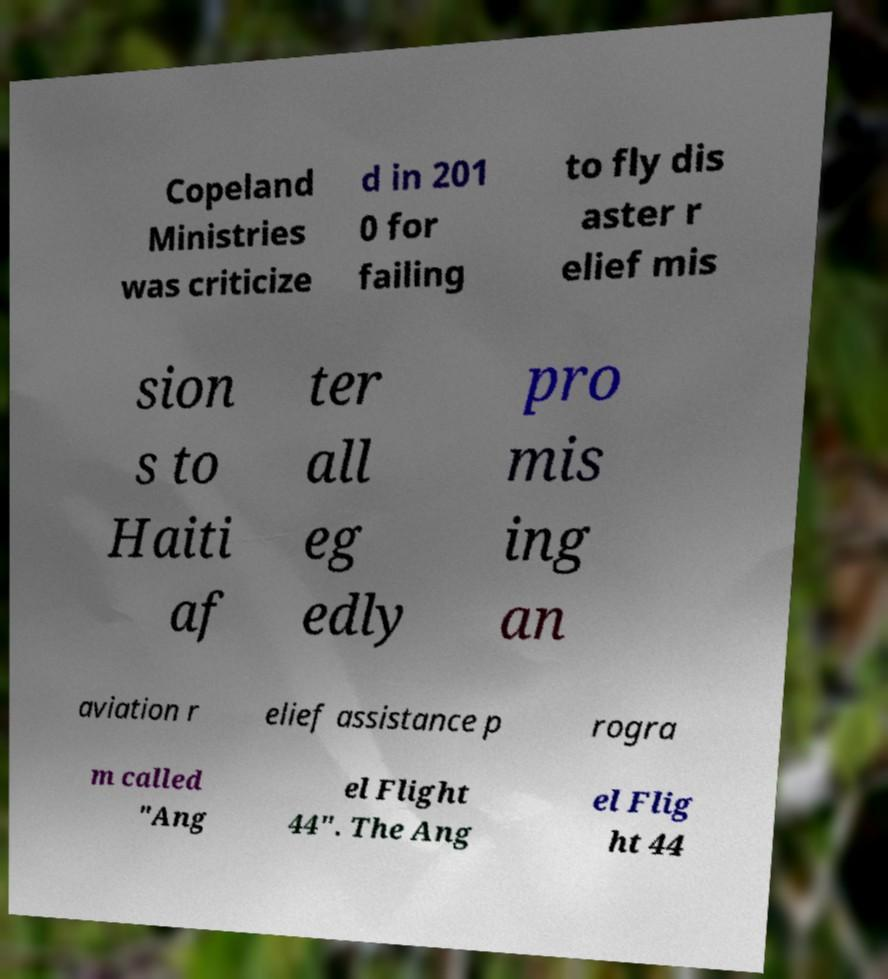Can you accurately transcribe the text from the provided image for me? Copeland Ministries was criticize d in 201 0 for failing to fly dis aster r elief mis sion s to Haiti af ter all eg edly pro mis ing an aviation r elief assistance p rogra m called "Ang el Flight 44". The Ang el Flig ht 44 